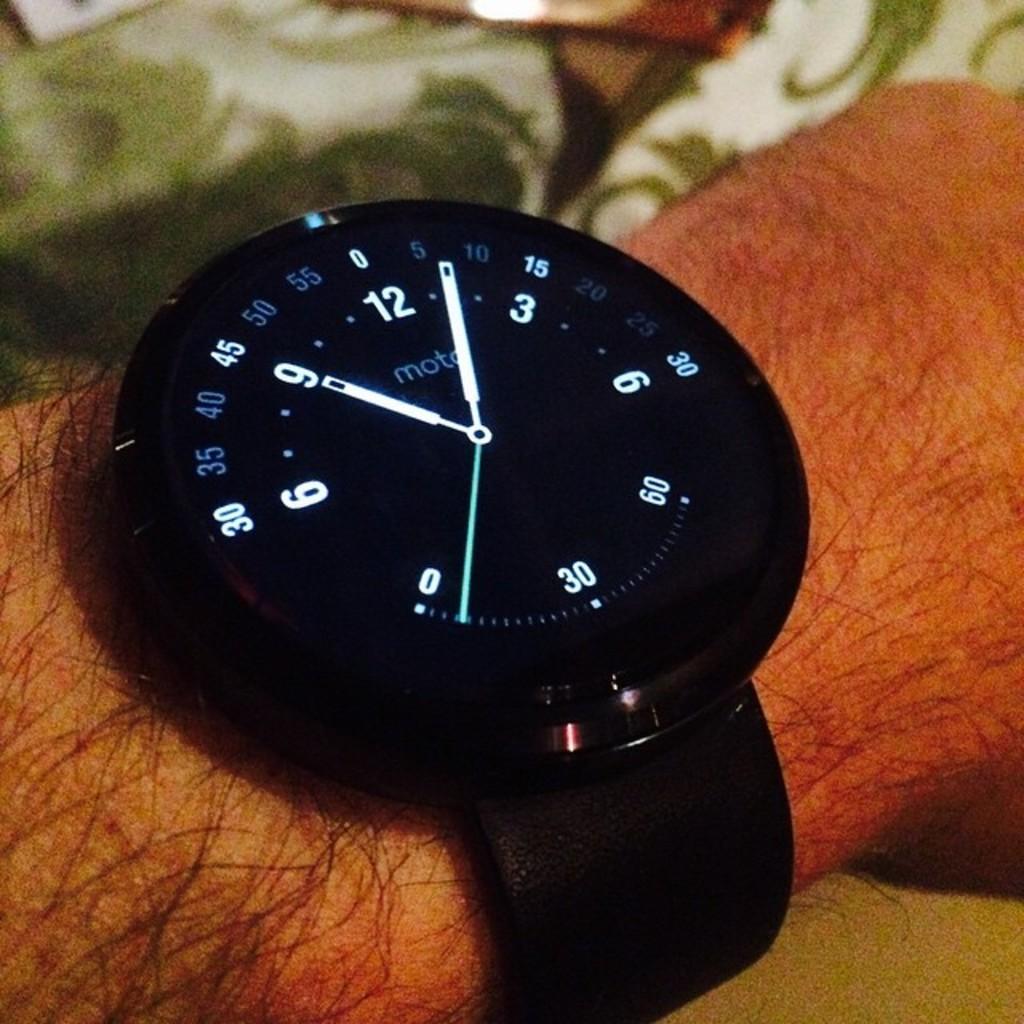What time is it on the watch?
Ensure brevity in your answer.  9:05. Is motorola into watch making too?
Ensure brevity in your answer.  Yes. 